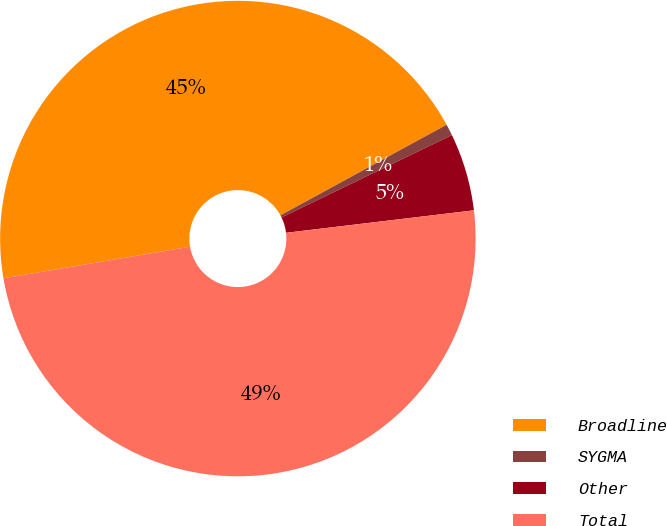Convert chart to OTSL. <chart><loc_0><loc_0><loc_500><loc_500><pie_chart><fcel>Broadline<fcel>SYGMA<fcel>Other<fcel>Total<nl><fcel>44.73%<fcel>0.78%<fcel>5.27%<fcel>49.22%<nl></chart> 